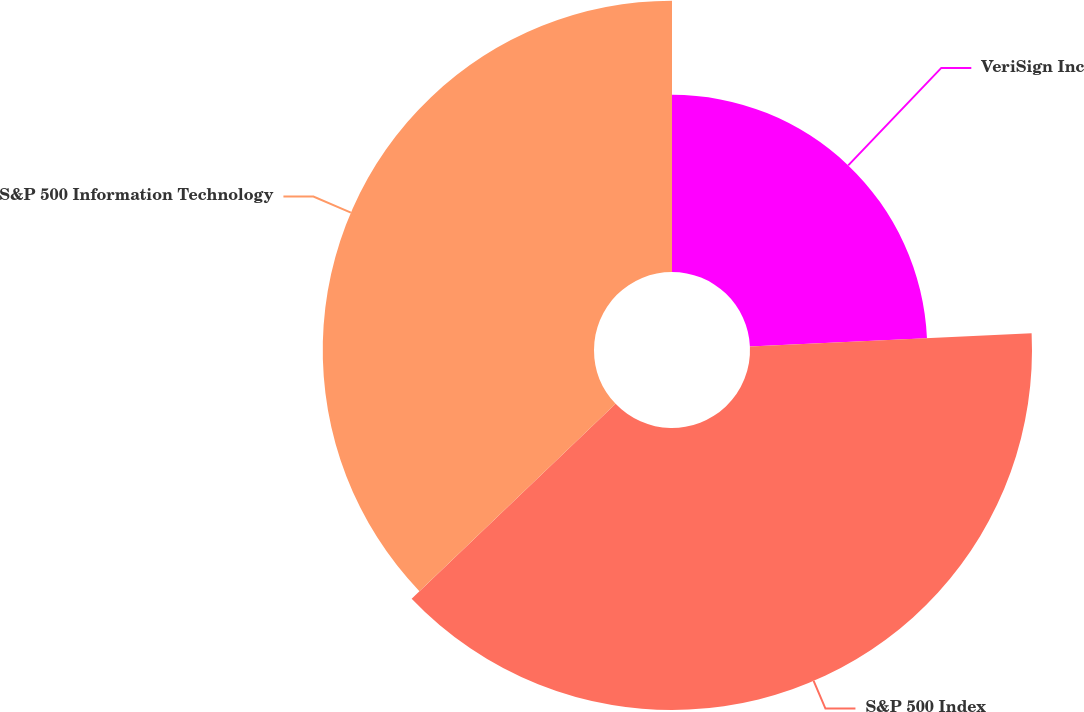<chart> <loc_0><loc_0><loc_500><loc_500><pie_chart><fcel>VeriSign Inc<fcel>S&P 500 Index<fcel>S&P 500 Information Technology<nl><fcel>24.26%<fcel>38.6%<fcel>37.13%<nl></chart> 